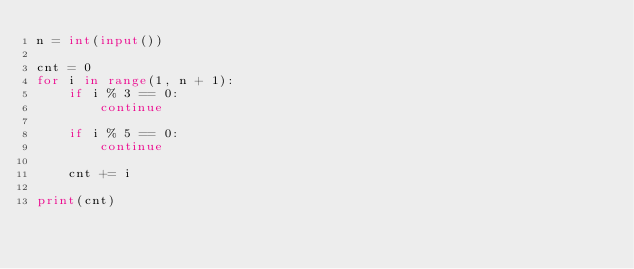Convert code to text. <code><loc_0><loc_0><loc_500><loc_500><_Python_>n = int(input())

cnt = 0
for i in range(1, n + 1):
    if i % 3 == 0:
        continue
    
    if i % 5 == 0:
        continue
    
    cnt += i
    
print(cnt)</code> 